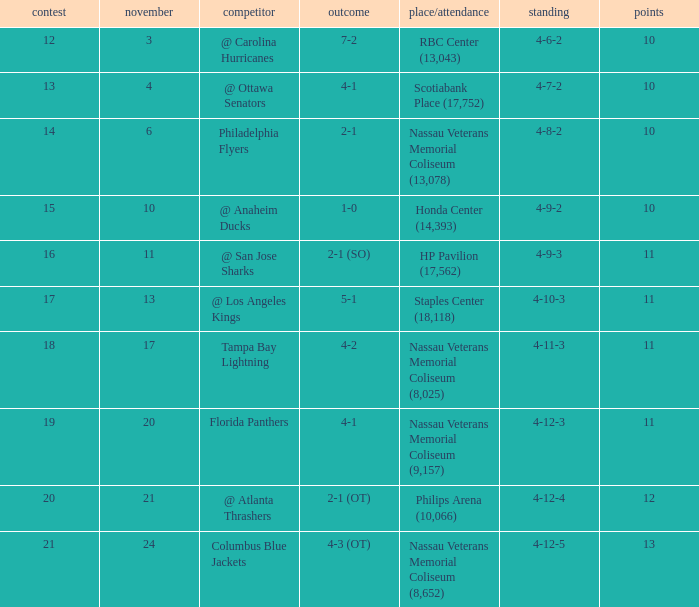What is every record for game 13? 4-7-2. 